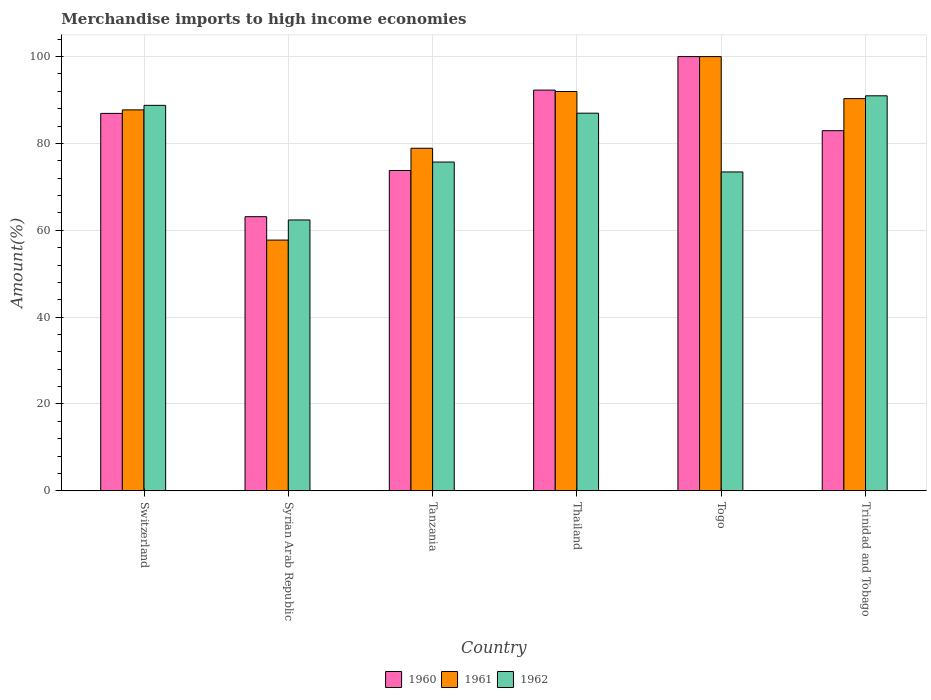Are the number of bars per tick equal to the number of legend labels?
Offer a very short reply. Yes. How many bars are there on the 5th tick from the left?
Offer a very short reply. 3. How many bars are there on the 6th tick from the right?
Your answer should be compact. 3. What is the label of the 2nd group of bars from the left?
Make the answer very short. Syrian Arab Republic. In how many cases, is the number of bars for a given country not equal to the number of legend labels?
Offer a very short reply. 0. Across all countries, what is the maximum percentage of amount earned from merchandise imports in 1960?
Offer a terse response. 100. Across all countries, what is the minimum percentage of amount earned from merchandise imports in 1961?
Make the answer very short. 57.74. In which country was the percentage of amount earned from merchandise imports in 1960 maximum?
Offer a terse response. Togo. In which country was the percentage of amount earned from merchandise imports in 1961 minimum?
Offer a terse response. Syrian Arab Republic. What is the total percentage of amount earned from merchandise imports in 1960 in the graph?
Give a very brief answer. 499.02. What is the difference between the percentage of amount earned from merchandise imports in 1961 in Switzerland and that in Tanzania?
Provide a succinct answer. 8.84. What is the difference between the percentage of amount earned from merchandise imports in 1962 in Togo and the percentage of amount earned from merchandise imports in 1961 in Thailand?
Provide a short and direct response. -18.52. What is the average percentage of amount earned from merchandise imports in 1960 per country?
Your answer should be very brief. 83.17. What is the difference between the percentage of amount earned from merchandise imports of/in 1960 and percentage of amount earned from merchandise imports of/in 1962 in Tanzania?
Offer a terse response. -1.95. What is the ratio of the percentage of amount earned from merchandise imports in 1961 in Syrian Arab Republic to that in Togo?
Give a very brief answer. 0.58. Is the percentage of amount earned from merchandise imports in 1961 in Switzerland less than that in Togo?
Offer a very short reply. Yes. What is the difference between the highest and the second highest percentage of amount earned from merchandise imports in 1960?
Ensure brevity in your answer.  13.08. What is the difference between the highest and the lowest percentage of amount earned from merchandise imports in 1962?
Offer a terse response. 28.6. In how many countries, is the percentage of amount earned from merchandise imports in 1960 greater than the average percentage of amount earned from merchandise imports in 1960 taken over all countries?
Provide a short and direct response. 3. Is the sum of the percentage of amount earned from merchandise imports in 1961 in Togo and Trinidad and Tobago greater than the maximum percentage of amount earned from merchandise imports in 1960 across all countries?
Ensure brevity in your answer.  Yes. What does the 1st bar from the right in Switzerland represents?
Ensure brevity in your answer.  1962. Is it the case that in every country, the sum of the percentage of amount earned from merchandise imports in 1961 and percentage of amount earned from merchandise imports in 1960 is greater than the percentage of amount earned from merchandise imports in 1962?
Give a very brief answer. Yes. How many bars are there?
Your answer should be very brief. 18. What is the difference between two consecutive major ticks on the Y-axis?
Keep it short and to the point. 20. Does the graph contain any zero values?
Give a very brief answer. No. Where does the legend appear in the graph?
Make the answer very short. Bottom center. How are the legend labels stacked?
Provide a short and direct response. Horizontal. What is the title of the graph?
Your answer should be compact. Merchandise imports to high income economies. What is the label or title of the Y-axis?
Provide a succinct answer. Amount(%). What is the Amount(%) of 1960 in Switzerland?
Provide a short and direct response. 86.92. What is the Amount(%) of 1961 in Switzerland?
Keep it short and to the point. 87.73. What is the Amount(%) in 1962 in Switzerland?
Ensure brevity in your answer.  88.77. What is the Amount(%) in 1960 in Syrian Arab Republic?
Your response must be concise. 63.13. What is the Amount(%) in 1961 in Syrian Arab Republic?
Make the answer very short. 57.74. What is the Amount(%) in 1962 in Syrian Arab Republic?
Offer a terse response. 62.37. What is the Amount(%) of 1960 in Tanzania?
Provide a succinct answer. 73.76. What is the Amount(%) in 1961 in Tanzania?
Offer a very short reply. 78.89. What is the Amount(%) in 1962 in Tanzania?
Offer a terse response. 75.71. What is the Amount(%) in 1960 in Thailand?
Your answer should be very brief. 92.28. What is the Amount(%) in 1961 in Thailand?
Offer a terse response. 91.95. What is the Amount(%) in 1962 in Thailand?
Your answer should be very brief. 86.97. What is the Amount(%) in 1960 in Togo?
Your answer should be compact. 100. What is the Amount(%) of 1962 in Togo?
Your answer should be very brief. 73.43. What is the Amount(%) in 1960 in Trinidad and Tobago?
Provide a succinct answer. 82.93. What is the Amount(%) in 1961 in Trinidad and Tobago?
Offer a very short reply. 90.32. What is the Amount(%) in 1962 in Trinidad and Tobago?
Provide a succinct answer. 90.97. Across all countries, what is the maximum Amount(%) in 1960?
Give a very brief answer. 100. Across all countries, what is the maximum Amount(%) of 1962?
Make the answer very short. 90.97. Across all countries, what is the minimum Amount(%) in 1960?
Your answer should be very brief. 63.13. Across all countries, what is the minimum Amount(%) of 1961?
Offer a very short reply. 57.74. Across all countries, what is the minimum Amount(%) of 1962?
Your response must be concise. 62.37. What is the total Amount(%) in 1960 in the graph?
Offer a terse response. 499.02. What is the total Amount(%) of 1961 in the graph?
Your response must be concise. 506.62. What is the total Amount(%) in 1962 in the graph?
Make the answer very short. 478.22. What is the difference between the Amount(%) of 1960 in Switzerland and that in Syrian Arab Republic?
Your response must be concise. 23.79. What is the difference between the Amount(%) of 1961 in Switzerland and that in Syrian Arab Republic?
Your response must be concise. 29.99. What is the difference between the Amount(%) of 1962 in Switzerland and that in Syrian Arab Republic?
Your answer should be very brief. 26.4. What is the difference between the Amount(%) in 1960 in Switzerland and that in Tanzania?
Provide a succinct answer. 13.16. What is the difference between the Amount(%) in 1961 in Switzerland and that in Tanzania?
Your answer should be compact. 8.84. What is the difference between the Amount(%) of 1962 in Switzerland and that in Tanzania?
Your response must be concise. 13.05. What is the difference between the Amount(%) in 1960 in Switzerland and that in Thailand?
Your answer should be compact. -5.36. What is the difference between the Amount(%) in 1961 in Switzerland and that in Thailand?
Your answer should be very brief. -4.22. What is the difference between the Amount(%) in 1962 in Switzerland and that in Thailand?
Ensure brevity in your answer.  1.8. What is the difference between the Amount(%) of 1960 in Switzerland and that in Togo?
Make the answer very short. -13.08. What is the difference between the Amount(%) in 1961 in Switzerland and that in Togo?
Offer a terse response. -12.27. What is the difference between the Amount(%) of 1962 in Switzerland and that in Togo?
Offer a very short reply. 15.34. What is the difference between the Amount(%) in 1960 in Switzerland and that in Trinidad and Tobago?
Your response must be concise. 3.98. What is the difference between the Amount(%) of 1961 in Switzerland and that in Trinidad and Tobago?
Your response must be concise. -2.59. What is the difference between the Amount(%) of 1962 in Switzerland and that in Trinidad and Tobago?
Your answer should be very brief. -2.2. What is the difference between the Amount(%) in 1960 in Syrian Arab Republic and that in Tanzania?
Keep it short and to the point. -10.63. What is the difference between the Amount(%) in 1961 in Syrian Arab Republic and that in Tanzania?
Offer a terse response. -21.15. What is the difference between the Amount(%) in 1962 in Syrian Arab Republic and that in Tanzania?
Your response must be concise. -13.34. What is the difference between the Amount(%) of 1960 in Syrian Arab Republic and that in Thailand?
Keep it short and to the point. -29.15. What is the difference between the Amount(%) in 1961 in Syrian Arab Republic and that in Thailand?
Your answer should be very brief. -34.21. What is the difference between the Amount(%) in 1962 in Syrian Arab Republic and that in Thailand?
Your answer should be compact. -24.59. What is the difference between the Amount(%) of 1960 in Syrian Arab Republic and that in Togo?
Provide a short and direct response. -36.87. What is the difference between the Amount(%) in 1961 in Syrian Arab Republic and that in Togo?
Your response must be concise. -42.26. What is the difference between the Amount(%) of 1962 in Syrian Arab Republic and that in Togo?
Make the answer very short. -11.06. What is the difference between the Amount(%) of 1960 in Syrian Arab Republic and that in Trinidad and Tobago?
Give a very brief answer. -19.81. What is the difference between the Amount(%) of 1961 in Syrian Arab Republic and that in Trinidad and Tobago?
Offer a terse response. -32.58. What is the difference between the Amount(%) of 1962 in Syrian Arab Republic and that in Trinidad and Tobago?
Your response must be concise. -28.6. What is the difference between the Amount(%) of 1960 in Tanzania and that in Thailand?
Make the answer very short. -18.52. What is the difference between the Amount(%) of 1961 in Tanzania and that in Thailand?
Your answer should be compact. -13.06. What is the difference between the Amount(%) of 1962 in Tanzania and that in Thailand?
Your response must be concise. -11.25. What is the difference between the Amount(%) of 1960 in Tanzania and that in Togo?
Offer a very short reply. -26.24. What is the difference between the Amount(%) in 1961 in Tanzania and that in Togo?
Give a very brief answer. -21.11. What is the difference between the Amount(%) in 1962 in Tanzania and that in Togo?
Provide a succinct answer. 2.28. What is the difference between the Amount(%) in 1960 in Tanzania and that in Trinidad and Tobago?
Ensure brevity in your answer.  -9.17. What is the difference between the Amount(%) of 1961 in Tanzania and that in Trinidad and Tobago?
Your answer should be very brief. -11.43. What is the difference between the Amount(%) in 1962 in Tanzania and that in Trinidad and Tobago?
Provide a short and direct response. -15.25. What is the difference between the Amount(%) of 1960 in Thailand and that in Togo?
Offer a very short reply. -7.72. What is the difference between the Amount(%) of 1961 in Thailand and that in Togo?
Your response must be concise. -8.05. What is the difference between the Amount(%) in 1962 in Thailand and that in Togo?
Give a very brief answer. 13.53. What is the difference between the Amount(%) of 1960 in Thailand and that in Trinidad and Tobago?
Ensure brevity in your answer.  9.35. What is the difference between the Amount(%) in 1961 in Thailand and that in Trinidad and Tobago?
Give a very brief answer. 1.63. What is the difference between the Amount(%) of 1962 in Thailand and that in Trinidad and Tobago?
Make the answer very short. -4. What is the difference between the Amount(%) in 1960 in Togo and that in Trinidad and Tobago?
Ensure brevity in your answer.  17.07. What is the difference between the Amount(%) in 1961 in Togo and that in Trinidad and Tobago?
Make the answer very short. 9.68. What is the difference between the Amount(%) of 1962 in Togo and that in Trinidad and Tobago?
Make the answer very short. -17.54. What is the difference between the Amount(%) in 1960 in Switzerland and the Amount(%) in 1961 in Syrian Arab Republic?
Give a very brief answer. 29.18. What is the difference between the Amount(%) of 1960 in Switzerland and the Amount(%) of 1962 in Syrian Arab Republic?
Your answer should be compact. 24.54. What is the difference between the Amount(%) in 1961 in Switzerland and the Amount(%) in 1962 in Syrian Arab Republic?
Your answer should be very brief. 25.36. What is the difference between the Amount(%) in 1960 in Switzerland and the Amount(%) in 1961 in Tanzania?
Give a very brief answer. 8.03. What is the difference between the Amount(%) of 1960 in Switzerland and the Amount(%) of 1962 in Tanzania?
Provide a short and direct response. 11.2. What is the difference between the Amount(%) in 1961 in Switzerland and the Amount(%) in 1962 in Tanzania?
Provide a short and direct response. 12.01. What is the difference between the Amount(%) in 1960 in Switzerland and the Amount(%) in 1961 in Thailand?
Provide a succinct answer. -5.04. What is the difference between the Amount(%) of 1960 in Switzerland and the Amount(%) of 1962 in Thailand?
Your answer should be compact. -0.05. What is the difference between the Amount(%) of 1961 in Switzerland and the Amount(%) of 1962 in Thailand?
Make the answer very short. 0.76. What is the difference between the Amount(%) of 1960 in Switzerland and the Amount(%) of 1961 in Togo?
Keep it short and to the point. -13.08. What is the difference between the Amount(%) of 1960 in Switzerland and the Amount(%) of 1962 in Togo?
Keep it short and to the point. 13.48. What is the difference between the Amount(%) in 1961 in Switzerland and the Amount(%) in 1962 in Togo?
Your answer should be very brief. 14.29. What is the difference between the Amount(%) of 1960 in Switzerland and the Amount(%) of 1961 in Trinidad and Tobago?
Provide a short and direct response. -3.4. What is the difference between the Amount(%) of 1960 in Switzerland and the Amount(%) of 1962 in Trinidad and Tobago?
Provide a short and direct response. -4.05. What is the difference between the Amount(%) of 1961 in Switzerland and the Amount(%) of 1962 in Trinidad and Tobago?
Your response must be concise. -3.24. What is the difference between the Amount(%) in 1960 in Syrian Arab Republic and the Amount(%) in 1961 in Tanzania?
Offer a terse response. -15.76. What is the difference between the Amount(%) in 1960 in Syrian Arab Republic and the Amount(%) in 1962 in Tanzania?
Offer a terse response. -12.59. What is the difference between the Amount(%) in 1961 in Syrian Arab Republic and the Amount(%) in 1962 in Tanzania?
Your answer should be compact. -17.98. What is the difference between the Amount(%) in 1960 in Syrian Arab Republic and the Amount(%) in 1961 in Thailand?
Keep it short and to the point. -28.82. What is the difference between the Amount(%) of 1960 in Syrian Arab Republic and the Amount(%) of 1962 in Thailand?
Your response must be concise. -23.84. What is the difference between the Amount(%) of 1961 in Syrian Arab Republic and the Amount(%) of 1962 in Thailand?
Offer a very short reply. -29.23. What is the difference between the Amount(%) in 1960 in Syrian Arab Republic and the Amount(%) in 1961 in Togo?
Give a very brief answer. -36.87. What is the difference between the Amount(%) of 1960 in Syrian Arab Republic and the Amount(%) of 1962 in Togo?
Your answer should be compact. -10.3. What is the difference between the Amount(%) in 1961 in Syrian Arab Republic and the Amount(%) in 1962 in Togo?
Your answer should be compact. -15.69. What is the difference between the Amount(%) of 1960 in Syrian Arab Republic and the Amount(%) of 1961 in Trinidad and Tobago?
Keep it short and to the point. -27.19. What is the difference between the Amount(%) in 1960 in Syrian Arab Republic and the Amount(%) in 1962 in Trinidad and Tobago?
Ensure brevity in your answer.  -27.84. What is the difference between the Amount(%) of 1961 in Syrian Arab Republic and the Amount(%) of 1962 in Trinidad and Tobago?
Keep it short and to the point. -33.23. What is the difference between the Amount(%) of 1960 in Tanzania and the Amount(%) of 1961 in Thailand?
Offer a very short reply. -18.19. What is the difference between the Amount(%) of 1960 in Tanzania and the Amount(%) of 1962 in Thailand?
Your response must be concise. -13.2. What is the difference between the Amount(%) of 1961 in Tanzania and the Amount(%) of 1962 in Thailand?
Ensure brevity in your answer.  -8.08. What is the difference between the Amount(%) of 1960 in Tanzania and the Amount(%) of 1961 in Togo?
Provide a short and direct response. -26.24. What is the difference between the Amount(%) in 1960 in Tanzania and the Amount(%) in 1962 in Togo?
Your answer should be compact. 0.33. What is the difference between the Amount(%) in 1961 in Tanzania and the Amount(%) in 1962 in Togo?
Offer a terse response. 5.45. What is the difference between the Amount(%) of 1960 in Tanzania and the Amount(%) of 1961 in Trinidad and Tobago?
Your answer should be very brief. -16.56. What is the difference between the Amount(%) of 1960 in Tanzania and the Amount(%) of 1962 in Trinidad and Tobago?
Your answer should be very brief. -17.21. What is the difference between the Amount(%) of 1961 in Tanzania and the Amount(%) of 1962 in Trinidad and Tobago?
Offer a terse response. -12.08. What is the difference between the Amount(%) of 1960 in Thailand and the Amount(%) of 1961 in Togo?
Provide a short and direct response. -7.72. What is the difference between the Amount(%) in 1960 in Thailand and the Amount(%) in 1962 in Togo?
Provide a short and direct response. 18.85. What is the difference between the Amount(%) in 1961 in Thailand and the Amount(%) in 1962 in Togo?
Offer a terse response. 18.52. What is the difference between the Amount(%) of 1960 in Thailand and the Amount(%) of 1961 in Trinidad and Tobago?
Make the answer very short. 1.96. What is the difference between the Amount(%) in 1960 in Thailand and the Amount(%) in 1962 in Trinidad and Tobago?
Your answer should be compact. 1.31. What is the difference between the Amount(%) in 1960 in Togo and the Amount(%) in 1961 in Trinidad and Tobago?
Provide a short and direct response. 9.68. What is the difference between the Amount(%) in 1960 in Togo and the Amount(%) in 1962 in Trinidad and Tobago?
Offer a terse response. 9.03. What is the difference between the Amount(%) of 1961 in Togo and the Amount(%) of 1962 in Trinidad and Tobago?
Provide a short and direct response. 9.03. What is the average Amount(%) of 1960 per country?
Keep it short and to the point. 83.17. What is the average Amount(%) of 1961 per country?
Your answer should be very brief. 84.44. What is the average Amount(%) of 1962 per country?
Your answer should be very brief. 79.7. What is the difference between the Amount(%) of 1960 and Amount(%) of 1961 in Switzerland?
Ensure brevity in your answer.  -0.81. What is the difference between the Amount(%) of 1960 and Amount(%) of 1962 in Switzerland?
Your answer should be very brief. -1.85. What is the difference between the Amount(%) of 1961 and Amount(%) of 1962 in Switzerland?
Your response must be concise. -1.04. What is the difference between the Amount(%) of 1960 and Amount(%) of 1961 in Syrian Arab Republic?
Your answer should be very brief. 5.39. What is the difference between the Amount(%) in 1960 and Amount(%) in 1962 in Syrian Arab Republic?
Your answer should be compact. 0.76. What is the difference between the Amount(%) of 1961 and Amount(%) of 1962 in Syrian Arab Republic?
Make the answer very short. -4.63. What is the difference between the Amount(%) of 1960 and Amount(%) of 1961 in Tanzania?
Your response must be concise. -5.13. What is the difference between the Amount(%) of 1960 and Amount(%) of 1962 in Tanzania?
Your answer should be very brief. -1.95. What is the difference between the Amount(%) in 1961 and Amount(%) in 1962 in Tanzania?
Offer a very short reply. 3.17. What is the difference between the Amount(%) in 1960 and Amount(%) in 1961 in Thailand?
Make the answer very short. 0.33. What is the difference between the Amount(%) in 1960 and Amount(%) in 1962 in Thailand?
Make the answer very short. 5.32. What is the difference between the Amount(%) of 1961 and Amount(%) of 1962 in Thailand?
Provide a short and direct response. 4.99. What is the difference between the Amount(%) of 1960 and Amount(%) of 1961 in Togo?
Your answer should be very brief. 0. What is the difference between the Amount(%) of 1960 and Amount(%) of 1962 in Togo?
Offer a terse response. 26.57. What is the difference between the Amount(%) of 1961 and Amount(%) of 1962 in Togo?
Ensure brevity in your answer.  26.57. What is the difference between the Amount(%) of 1960 and Amount(%) of 1961 in Trinidad and Tobago?
Offer a terse response. -7.38. What is the difference between the Amount(%) in 1960 and Amount(%) in 1962 in Trinidad and Tobago?
Your answer should be very brief. -8.03. What is the difference between the Amount(%) in 1961 and Amount(%) in 1962 in Trinidad and Tobago?
Ensure brevity in your answer.  -0.65. What is the ratio of the Amount(%) of 1960 in Switzerland to that in Syrian Arab Republic?
Give a very brief answer. 1.38. What is the ratio of the Amount(%) in 1961 in Switzerland to that in Syrian Arab Republic?
Your answer should be very brief. 1.52. What is the ratio of the Amount(%) of 1962 in Switzerland to that in Syrian Arab Republic?
Your answer should be very brief. 1.42. What is the ratio of the Amount(%) of 1960 in Switzerland to that in Tanzania?
Keep it short and to the point. 1.18. What is the ratio of the Amount(%) of 1961 in Switzerland to that in Tanzania?
Give a very brief answer. 1.11. What is the ratio of the Amount(%) of 1962 in Switzerland to that in Tanzania?
Your answer should be very brief. 1.17. What is the ratio of the Amount(%) in 1960 in Switzerland to that in Thailand?
Your response must be concise. 0.94. What is the ratio of the Amount(%) of 1961 in Switzerland to that in Thailand?
Your answer should be very brief. 0.95. What is the ratio of the Amount(%) in 1962 in Switzerland to that in Thailand?
Your response must be concise. 1.02. What is the ratio of the Amount(%) of 1960 in Switzerland to that in Togo?
Your response must be concise. 0.87. What is the ratio of the Amount(%) in 1961 in Switzerland to that in Togo?
Your response must be concise. 0.88. What is the ratio of the Amount(%) in 1962 in Switzerland to that in Togo?
Keep it short and to the point. 1.21. What is the ratio of the Amount(%) in 1960 in Switzerland to that in Trinidad and Tobago?
Provide a short and direct response. 1.05. What is the ratio of the Amount(%) of 1961 in Switzerland to that in Trinidad and Tobago?
Your response must be concise. 0.97. What is the ratio of the Amount(%) in 1962 in Switzerland to that in Trinidad and Tobago?
Your response must be concise. 0.98. What is the ratio of the Amount(%) in 1960 in Syrian Arab Republic to that in Tanzania?
Make the answer very short. 0.86. What is the ratio of the Amount(%) of 1961 in Syrian Arab Republic to that in Tanzania?
Keep it short and to the point. 0.73. What is the ratio of the Amount(%) of 1962 in Syrian Arab Republic to that in Tanzania?
Your answer should be compact. 0.82. What is the ratio of the Amount(%) of 1960 in Syrian Arab Republic to that in Thailand?
Provide a succinct answer. 0.68. What is the ratio of the Amount(%) in 1961 in Syrian Arab Republic to that in Thailand?
Your answer should be very brief. 0.63. What is the ratio of the Amount(%) in 1962 in Syrian Arab Republic to that in Thailand?
Your answer should be compact. 0.72. What is the ratio of the Amount(%) in 1960 in Syrian Arab Republic to that in Togo?
Keep it short and to the point. 0.63. What is the ratio of the Amount(%) of 1961 in Syrian Arab Republic to that in Togo?
Make the answer very short. 0.58. What is the ratio of the Amount(%) of 1962 in Syrian Arab Republic to that in Togo?
Provide a short and direct response. 0.85. What is the ratio of the Amount(%) in 1960 in Syrian Arab Republic to that in Trinidad and Tobago?
Provide a succinct answer. 0.76. What is the ratio of the Amount(%) in 1961 in Syrian Arab Republic to that in Trinidad and Tobago?
Ensure brevity in your answer.  0.64. What is the ratio of the Amount(%) of 1962 in Syrian Arab Republic to that in Trinidad and Tobago?
Offer a very short reply. 0.69. What is the ratio of the Amount(%) of 1960 in Tanzania to that in Thailand?
Give a very brief answer. 0.8. What is the ratio of the Amount(%) in 1961 in Tanzania to that in Thailand?
Offer a very short reply. 0.86. What is the ratio of the Amount(%) in 1962 in Tanzania to that in Thailand?
Offer a terse response. 0.87. What is the ratio of the Amount(%) of 1960 in Tanzania to that in Togo?
Give a very brief answer. 0.74. What is the ratio of the Amount(%) in 1961 in Tanzania to that in Togo?
Provide a short and direct response. 0.79. What is the ratio of the Amount(%) of 1962 in Tanzania to that in Togo?
Provide a succinct answer. 1.03. What is the ratio of the Amount(%) of 1960 in Tanzania to that in Trinidad and Tobago?
Provide a short and direct response. 0.89. What is the ratio of the Amount(%) in 1961 in Tanzania to that in Trinidad and Tobago?
Provide a short and direct response. 0.87. What is the ratio of the Amount(%) of 1962 in Tanzania to that in Trinidad and Tobago?
Provide a succinct answer. 0.83. What is the ratio of the Amount(%) in 1960 in Thailand to that in Togo?
Ensure brevity in your answer.  0.92. What is the ratio of the Amount(%) of 1961 in Thailand to that in Togo?
Your response must be concise. 0.92. What is the ratio of the Amount(%) in 1962 in Thailand to that in Togo?
Make the answer very short. 1.18. What is the ratio of the Amount(%) of 1960 in Thailand to that in Trinidad and Tobago?
Offer a very short reply. 1.11. What is the ratio of the Amount(%) of 1961 in Thailand to that in Trinidad and Tobago?
Ensure brevity in your answer.  1.02. What is the ratio of the Amount(%) in 1962 in Thailand to that in Trinidad and Tobago?
Provide a short and direct response. 0.96. What is the ratio of the Amount(%) in 1960 in Togo to that in Trinidad and Tobago?
Give a very brief answer. 1.21. What is the ratio of the Amount(%) of 1961 in Togo to that in Trinidad and Tobago?
Provide a succinct answer. 1.11. What is the ratio of the Amount(%) of 1962 in Togo to that in Trinidad and Tobago?
Make the answer very short. 0.81. What is the difference between the highest and the second highest Amount(%) of 1960?
Offer a terse response. 7.72. What is the difference between the highest and the second highest Amount(%) of 1961?
Your answer should be compact. 8.05. What is the difference between the highest and the second highest Amount(%) in 1962?
Your answer should be very brief. 2.2. What is the difference between the highest and the lowest Amount(%) of 1960?
Your answer should be compact. 36.87. What is the difference between the highest and the lowest Amount(%) in 1961?
Offer a terse response. 42.26. What is the difference between the highest and the lowest Amount(%) of 1962?
Your answer should be compact. 28.6. 